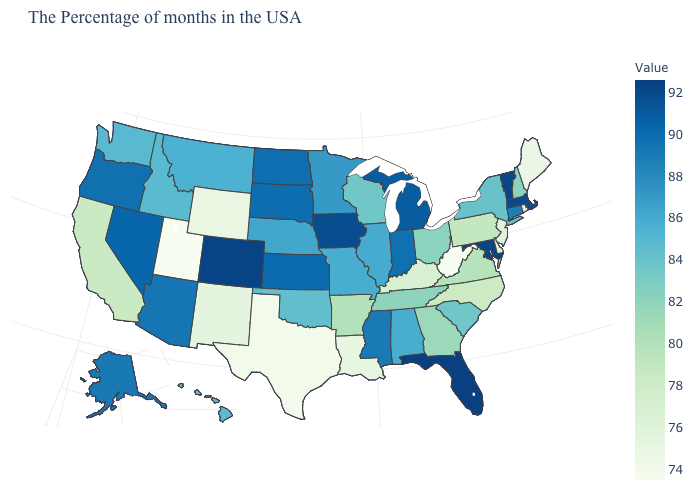Does the map have missing data?
Be succinct. No. Does North Carolina have a higher value than Rhode Island?
Give a very brief answer. Yes. Among the states that border New Jersey , does Pennsylvania have the highest value?
Short answer required. No. Does West Virginia have the lowest value in the South?
Quick response, please. Yes. 